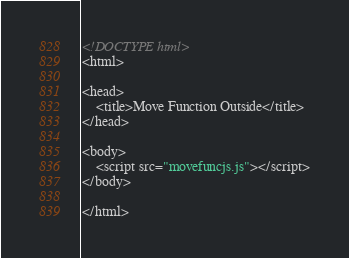<code> <loc_0><loc_0><loc_500><loc_500><_HTML_><!DOCTYPE html>
<html>

<head>
    <title>Move Function Outside</title>
</head>

<body>
    <script src="movefuncjs.js"></script>
</body>

</html></code> 